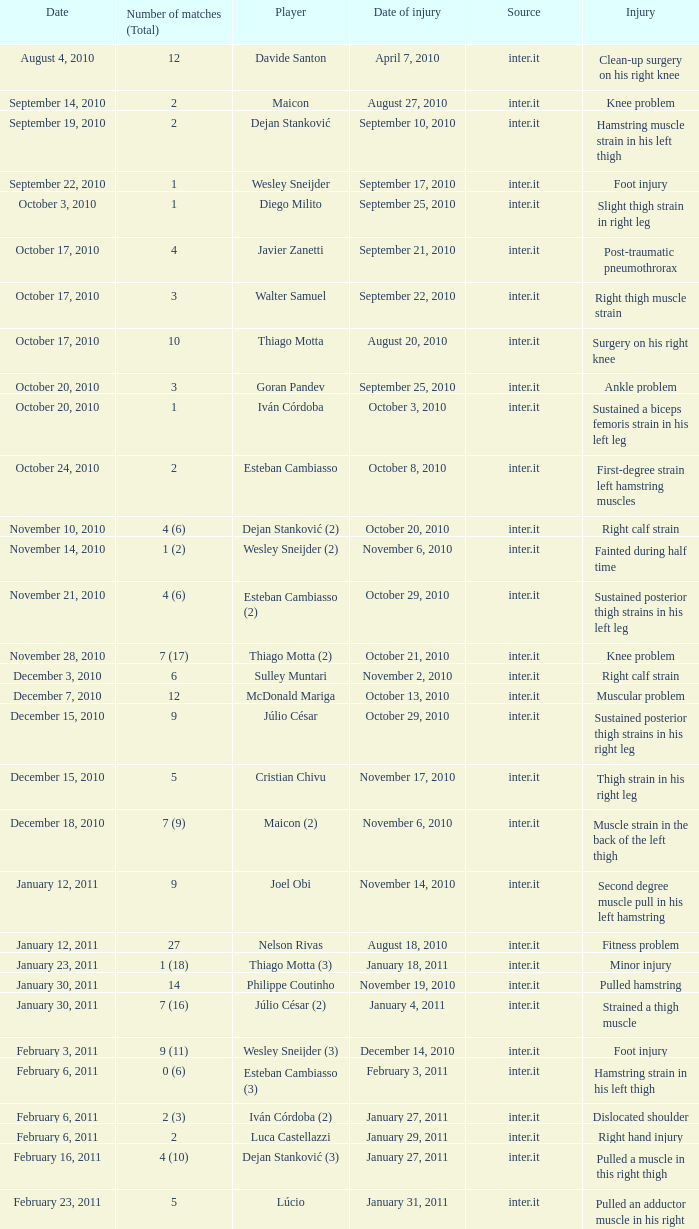What is the date of injury when the injury is foot injury and the number of matches (total) is 1? September 17, 2010. 